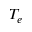<formula> <loc_0><loc_0><loc_500><loc_500>T _ { e }</formula> 